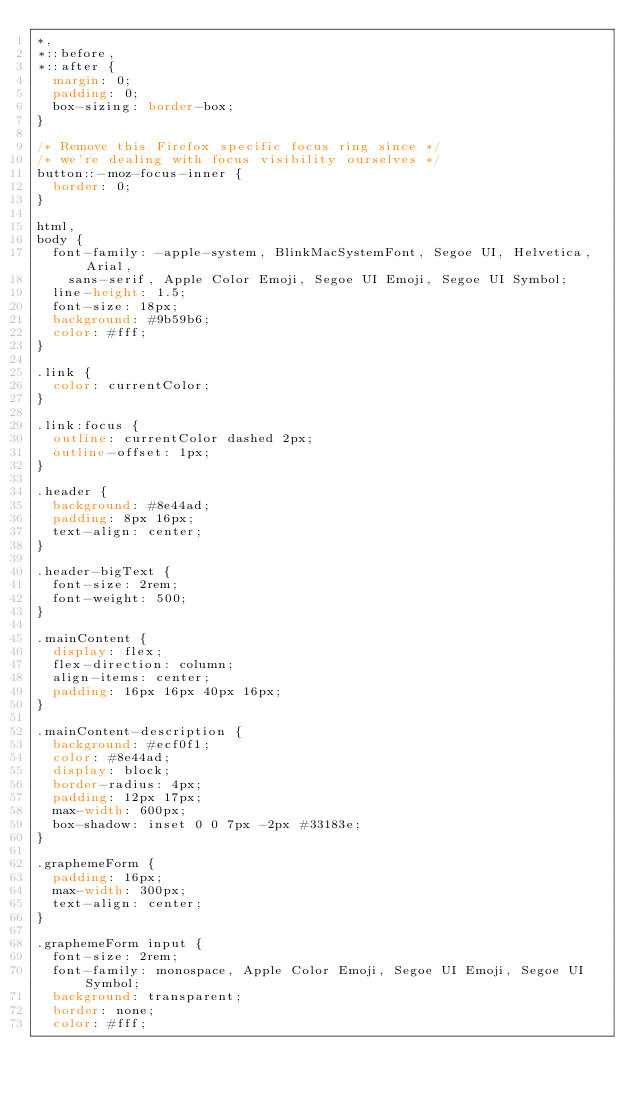<code> <loc_0><loc_0><loc_500><loc_500><_CSS_>*,
*::before,
*::after {
  margin: 0;
  padding: 0;
  box-sizing: border-box;
}

/* Remove this Firefox specific focus ring since */
/* we're dealing with focus visibility ourselves */
button::-moz-focus-inner {
  border: 0;
}

html,
body {
  font-family: -apple-system, BlinkMacSystemFont, Segoe UI, Helvetica, Arial,
    sans-serif, Apple Color Emoji, Segoe UI Emoji, Segoe UI Symbol;
  line-height: 1.5;
  font-size: 18px;
  background: #9b59b6;
  color: #fff;
}

.link {
  color: currentColor;
}

.link:focus {
  outline: currentColor dashed 2px;
  outline-offset: 1px;
}

.header {
  background: #8e44ad;
  padding: 8px 16px;
  text-align: center;
}

.header-bigText {
  font-size: 2rem;
  font-weight: 500;
}

.mainContent {
  display: flex;
  flex-direction: column;
  align-items: center;
  padding: 16px 16px 40px 16px;
}

.mainContent-description {
  background: #ecf0f1;
  color: #8e44ad;
  display: block;
  border-radius: 4px;
  padding: 12px 17px;
  max-width: 600px;
  box-shadow: inset 0 0 7px -2px #33183e;
}

.graphemeForm {
  padding: 16px;
  max-width: 300px;
  text-align: center;
}

.graphemeForm input {
  font-size: 2rem;
  font-family: monospace, Apple Color Emoji, Segoe UI Emoji, Segoe UI Symbol;
  background: transparent;
  border: none;
  color: #fff;</code> 